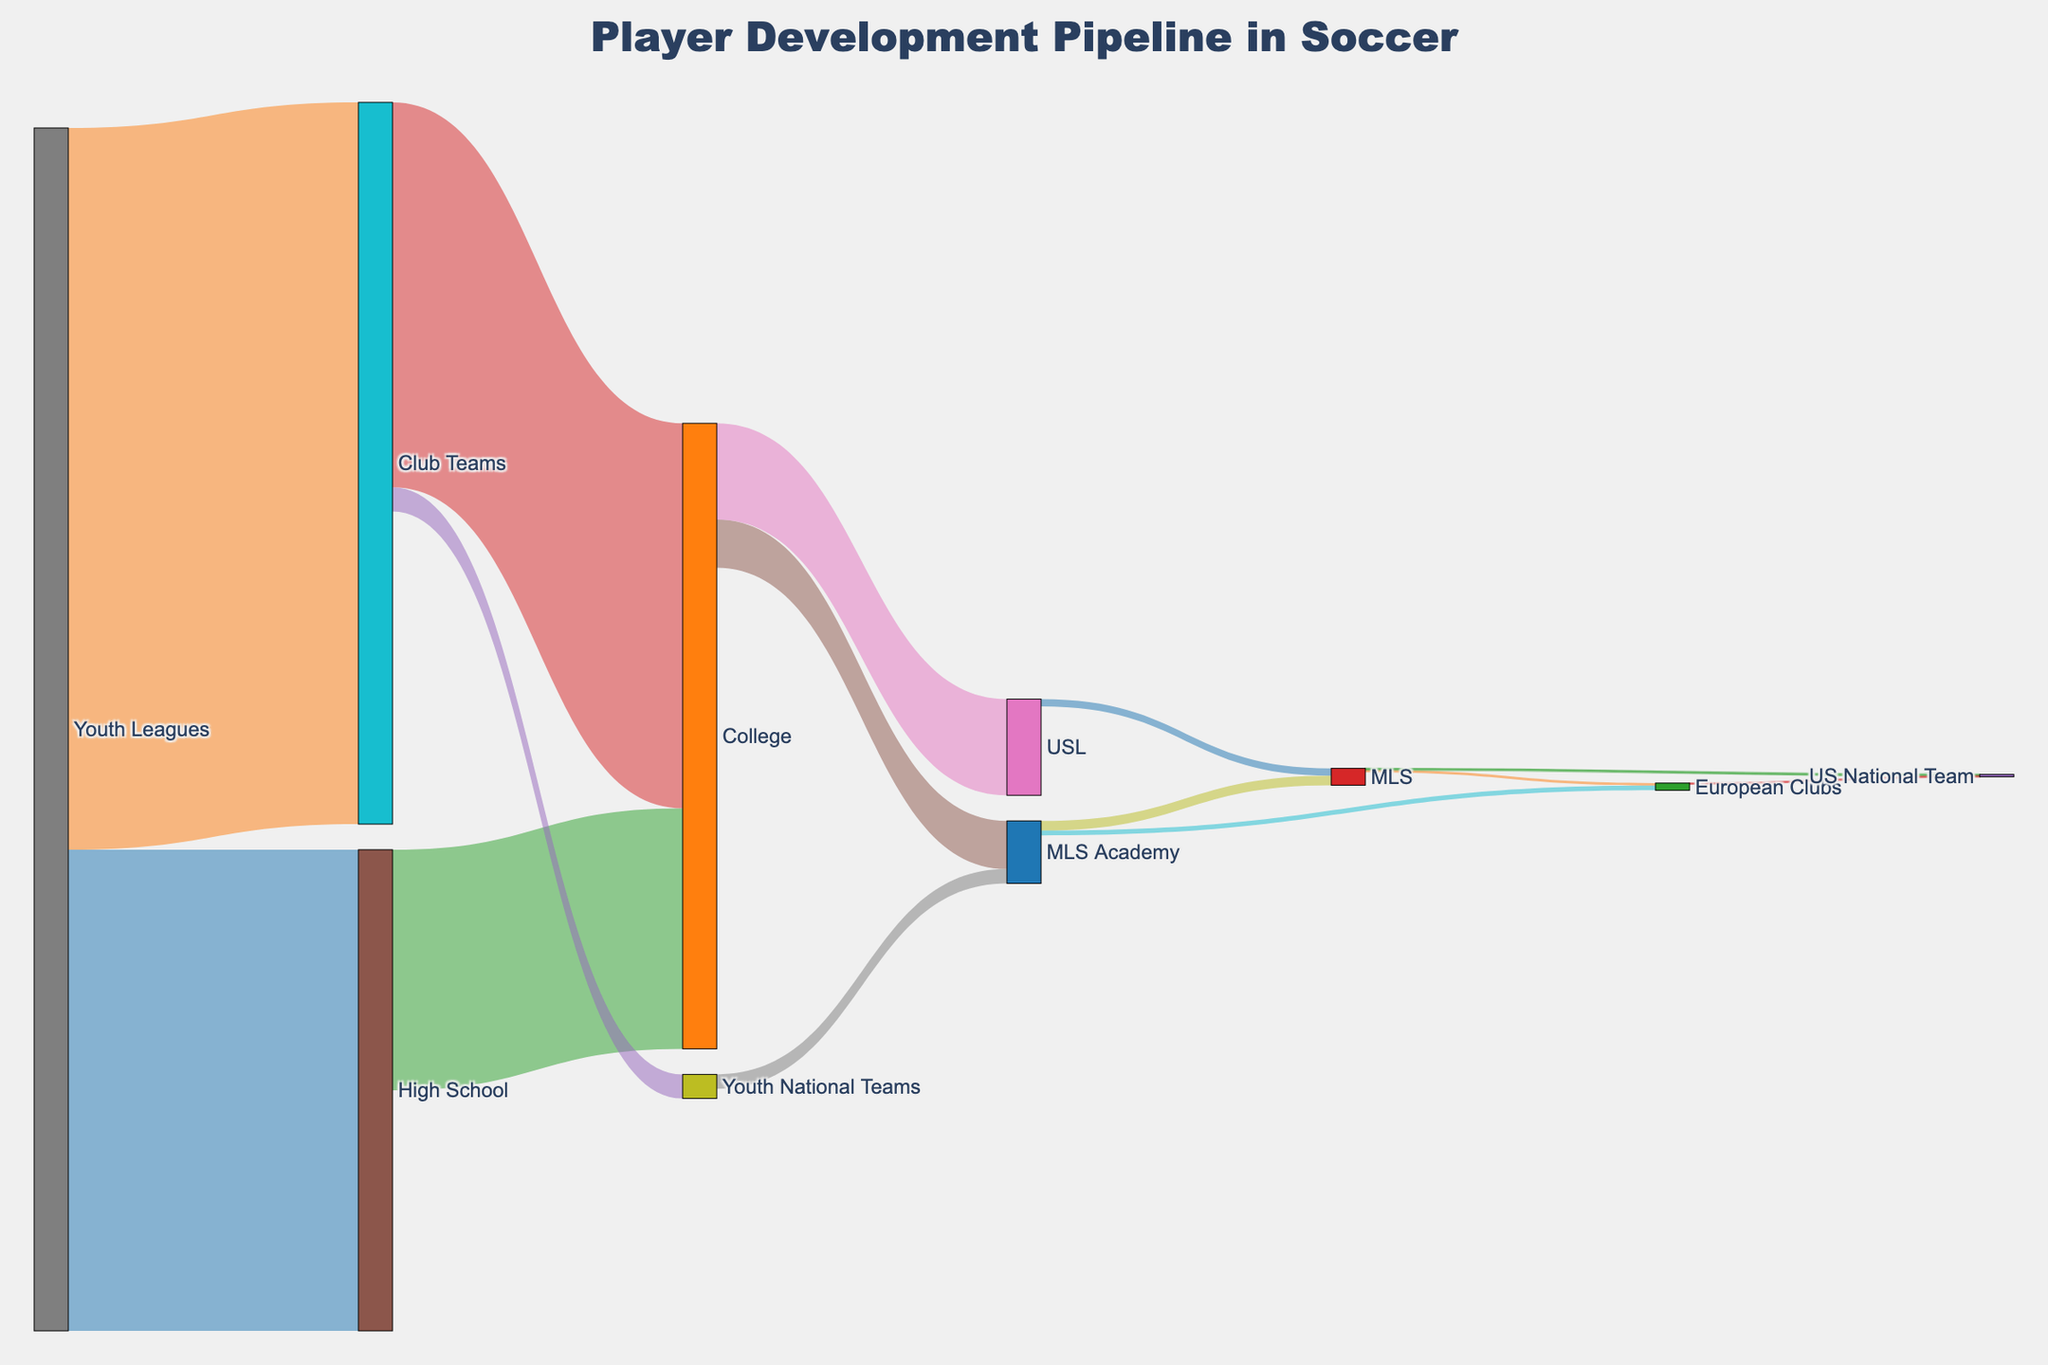What stage has the highest number of players moving to High School? The stage with the highest number of players moving to High School is Youth Leagues. The flow from Youth Leagues to High School is 10,000 players.
Answer: Youth Leagues How many players move from Club Teams to College? The flow from Club Teams to College in the Sankey diagram is represented by the line between these two stages. The number of players is 8,000.
Answer: 8,000 Which has more players moving to the US National Team, MLS or European Clubs? The line from MLS to US National Team shows 30 players, and the line from European Clubs to US National Team shows 20 players.
Answer: MLS How many players transition from Youth Leagues to High School and then to College? First, identify the flow from Youth Leagues to High School (10,000). Then, find the flow from High School to College (5,000). Because the Sankey diagram shows straight flows, assume all come from previous steps without deviations.
Answer: 5,000 What is the total number of players transitioning to professional teams (MLS and European Clubs) from MLS Academy? Add the players moving from MLS Academy to MLS (200) and those moving from MLS Academy to European Clubs (100). The total is 200 + 100 = 300.
Answer: 300 How many players transition to professional leagues (MLS and USL) from College? Add the number of players moving from College to MLS Academy (1,000) and College to USL (2,000). Then, within MLS Academy, find how many go to MLS (200), and directly from USL to MLS (150). Sum it all up: 1,000 + 200 + 2,000 + 150 = 3,350.
Answer: 3,350 Are there more players moving to College from High School or Club Teams? The flow from High School to College is 5,000, whereas from Club Teams to College is 8,000.
Answer: Club Teams What is the total number of players transitioning directly from youth stages (Youth Leagues, High School, Club Teams) to college? The transitions are: Youth Leagues to High School (10,000), High School to College (5,000), and Club Teams to College (8,000). The total is 5,000 from High School + 8,000 from Club Teams = 13,000.
Answer: 13,000 What path shows the highest flow of players into professional soccer? The paths to professional soccer primarily involve flows into MLS and European Clubs. The highest flow is from Club Teams to College (8,000), then predict movement to MLS Academy (1,000), eventually leading to MLS (200) or European Clubs (100). The pure flow shows more in Club Teams than other pathways.
Answer: Club Teams Compare the number of players moving from MLS Academy to MLS versus those moving from MLS to European Clubs. The flow from MLS Academy to MLS is 200, whereas from MLS to European Clubs is 50. Therefore, more players transition from MLS Academy directly to MLS than from MLS to European Clubs.
Answer: MLS Academy to MLS 